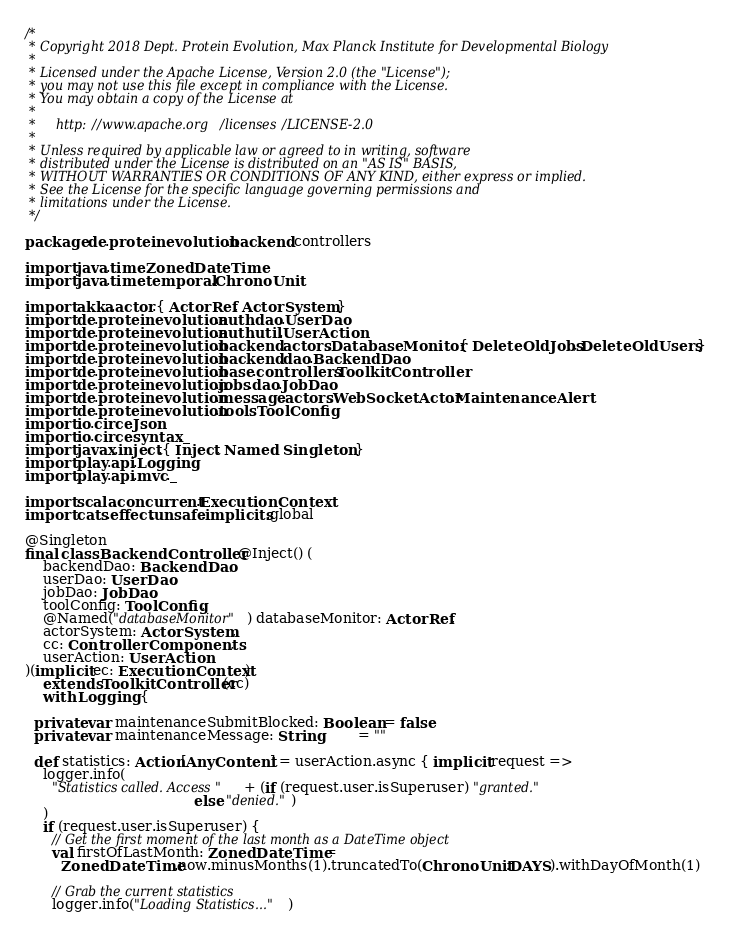<code> <loc_0><loc_0><loc_500><loc_500><_Scala_>/*
 * Copyright 2018 Dept. Protein Evolution, Max Planck Institute for Developmental Biology
 *
 * Licensed under the Apache License, Version 2.0 (the "License");
 * you may not use this file except in compliance with the License.
 * You may obtain a copy of the License at
 *
 *     http://www.apache.org/licenses/LICENSE-2.0
 *
 * Unless required by applicable law or agreed to in writing, software
 * distributed under the License is distributed on an "AS IS" BASIS,
 * WITHOUT WARRANTIES OR CONDITIONS OF ANY KIND, either express or implied.
 * See the License for the specific language governing permissions and
 * limitations under the License.
 */

package de.proteinevolution.backend.controllers

import java.time.ZonedDateTime
import java.time.temporal.ChronoUnit

import akka.actor.{ ActorRef, ActorSystem }
import de.proteinevolution.auth.dao.UserDao
import de.proteinevolution.auth.util.UserAction
import de.proteinevolution.backend.actors.DatabaseMonitor.{ DeleteOldJobs, DeleteOldUsers }
import de.proteinevolution.backend.dao.BackendDao
import de.proteinevolution.base.controllers.ToolkitController
import de.proteinevolution.jobs.dao.JobDao
import de.proteinevolution.message.actors.WebSocketActor.MaintenanceAlert
import de.proteinevolution.tools.ToolConfig
import io.circe.Json
import io.circe.syntax._
import javax.inject.{ Inject, Named, Singleton }
import play.api.Logging
import play.api.mvc._

import scala.concurrent.ExecutionContext
import cats.effect.unsafe.implicits.global

@Singleton
final class BackendController @Inject() (
    backendDao: BackendDao,
    userDao: UserDao,
    jobDao: JobDao,
    toolConfig: ToolConfig,
    @Named("databaseMonitor") databaseMonitor: ActorRef,
    actorSystem: ActorSystem,
    cc: ControllerComponents,
    userAction: UserAction
)(implicit ec: ExecutionContext)
    extends ToolkitController(cc)
    with Logging {

  private var maintenanceSubmitBlocked: Boolean = false
  private var maintenanceMessage: String        = ""

  def statistics: Action[AnyContent] = userAction.async { implicit request =>
    logger.info(
      "Statistics called. Access " + (if (request.user.isSuperuser) "granted."
                                      else "denied.")
    )
    if (request.user.isSuperuser) {
      // Get the first moment of the last month as a DateTime object
      val firstOfLastMonth: ZonedDateTime =
        ZonedDateTime.now.minusMonths(1).truncatedTo(ChronoUnit.DAYS).withDayOfMonth(1)

      // Grab the current statistics
      logger.info("Loading Statistics...")</code> 